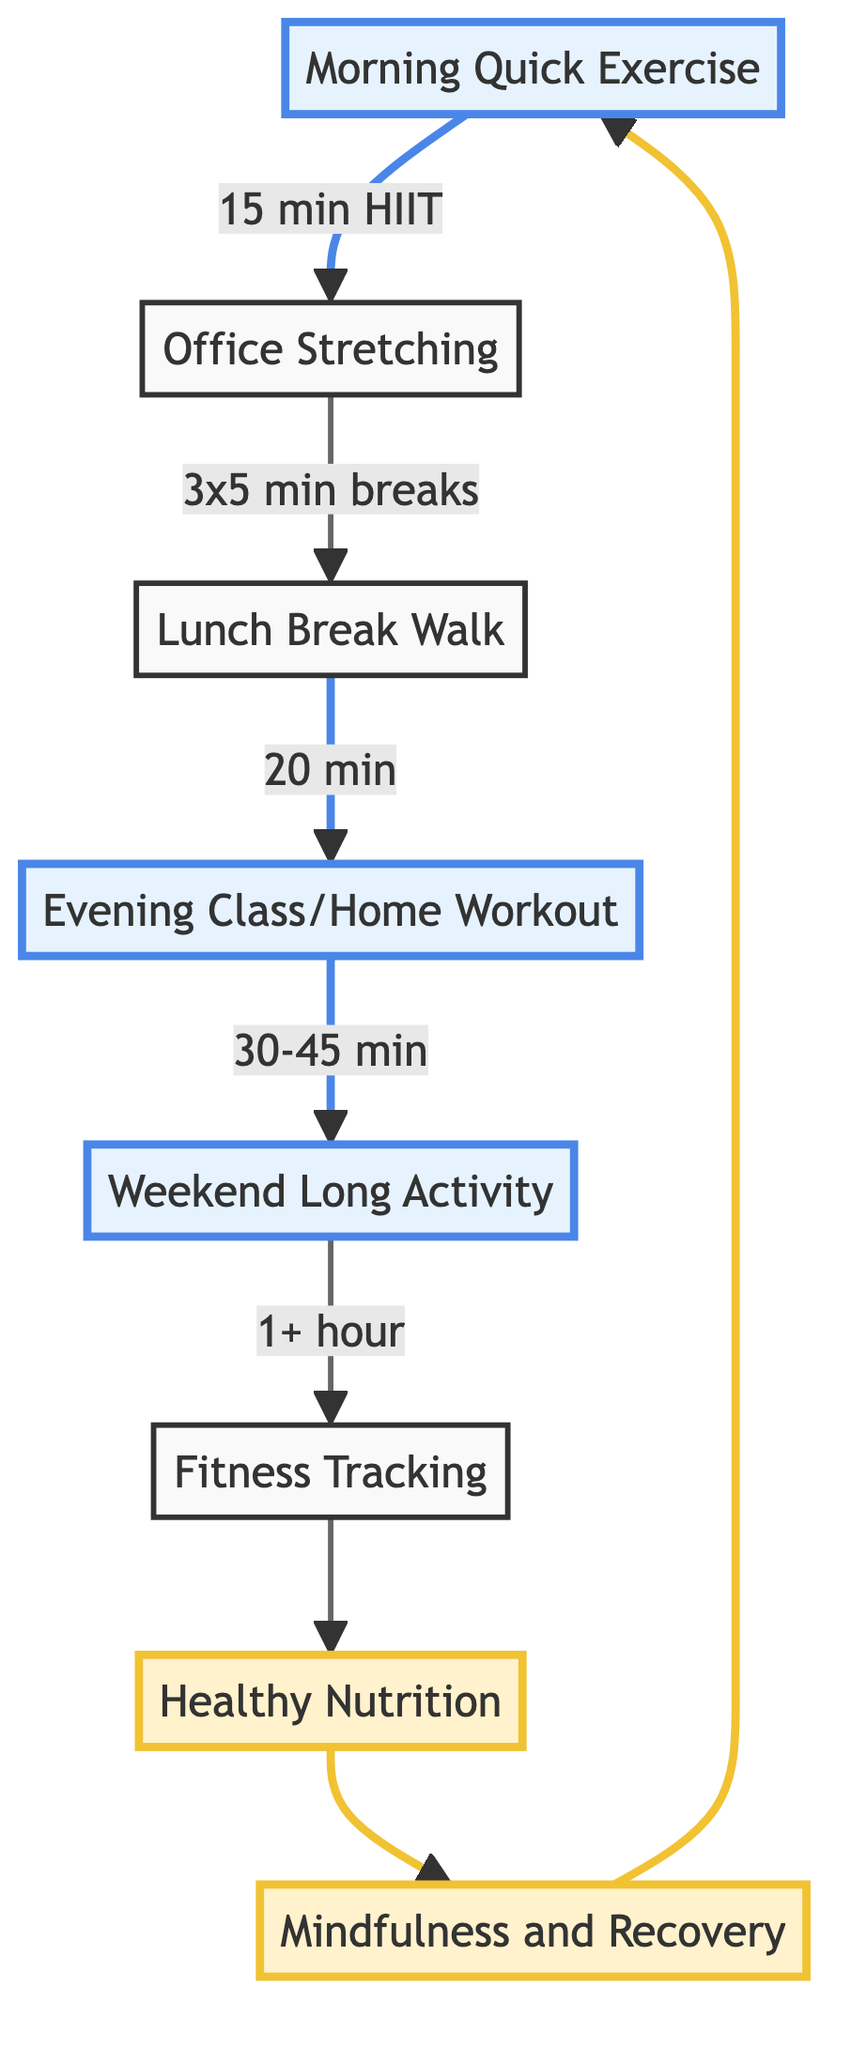What is the first step in the fitness routine? The diagram begins with "Morning Quick Exercise," indicating it's the starting point of the pathway.
Answer: Morning Quick Exercise How long is the recommended duration for "Evening Class or Home Workout"? The diagram specifies that the duration is "30-45 minutes," directly noted next to that step.
Answer: 30-45 minutes What activity follows the "Lunch Break Walk"? The flow indicates that after "Lunch Break Walk," the next activity is "Evening Class or Home Workout."
Answer: Evening Class/Home Workout Which activities involve tracking or monitoring progress? The diagram highlights "Fitness Tracking" which indicates monitoring, and also shows "Healthy Nutrition" which can be associated with tracking nutrition.
Answer: Fitness Tracking, Healthy Nutrition How many stretching sessions are recommended during work hours? The diagram explicitly states "3 stretching sessions" next to the "Office Stretching" node, confirming the number.
Answer: 3 What is the total time commitment for the activities listed from "Morning Quick Exercise" to "Weekend Long Activity"? To compute the total time, we add: 15 minutes (morning) + 15 minutes (office) + 20 minutes (lunch) + 30-45 minutes (evening) + 60 minutes (weekend) which equals a minimum of around 140 minutes to a maximum of 155 minutes.
Answer: 140-155 minutes What focus do "Mindfulness and Recovery" sessions serve? This step emphasizes incorporating mindfulness practices or recovery sessions, signifying their role in post-workout routines and wellness.
Answer: Recovery and Mindfulness Which two nodes are linked with a dashed line indicating emphasis on nutrition? The linking style shows that "Fitness Tracking" connects with "Healthy Nutrition," emphasizing their relationship through a unique color and style.
Answer: Fitness Tracking, Healthy Nutrition 